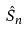Convert formula to latex. <formula><loc_0><loc_0><loc_500><loc_500>\hat { S } _ { n }</formula> 